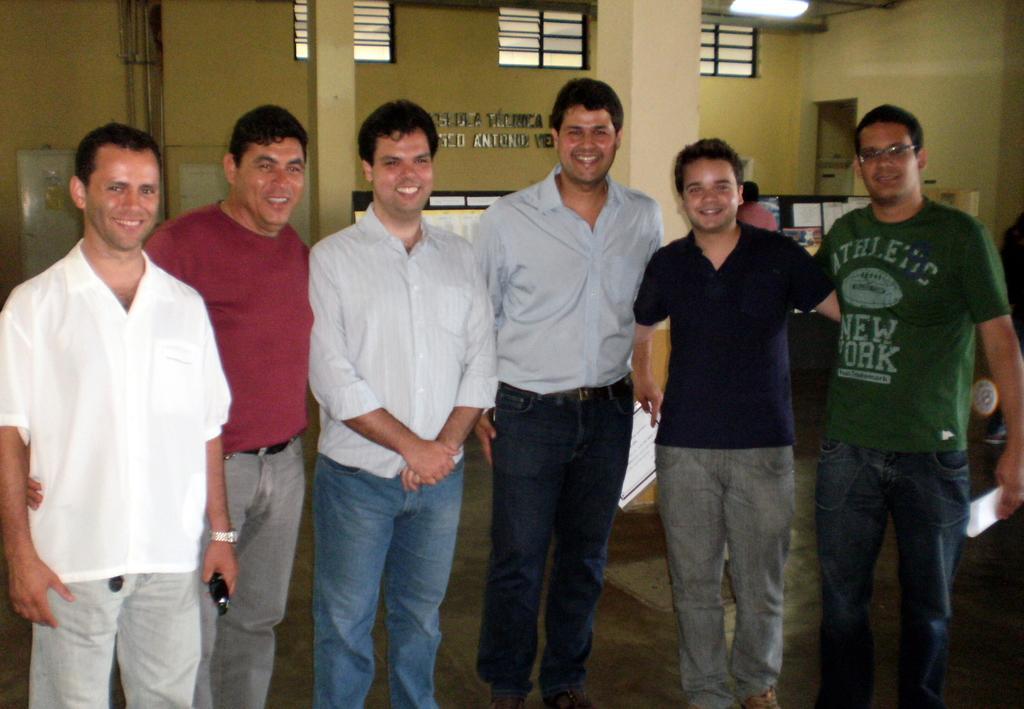Could you give a brief overview of what you see in this image? There are six people standing in front of the picture. Behind them, we see a man in pink T-shirt is sitting on the chair in front of him, we see a table on which laptop and monitor are placed. Behind them, we see pillars and a wall with some text written on it. At the top of the picture, we see the light. 